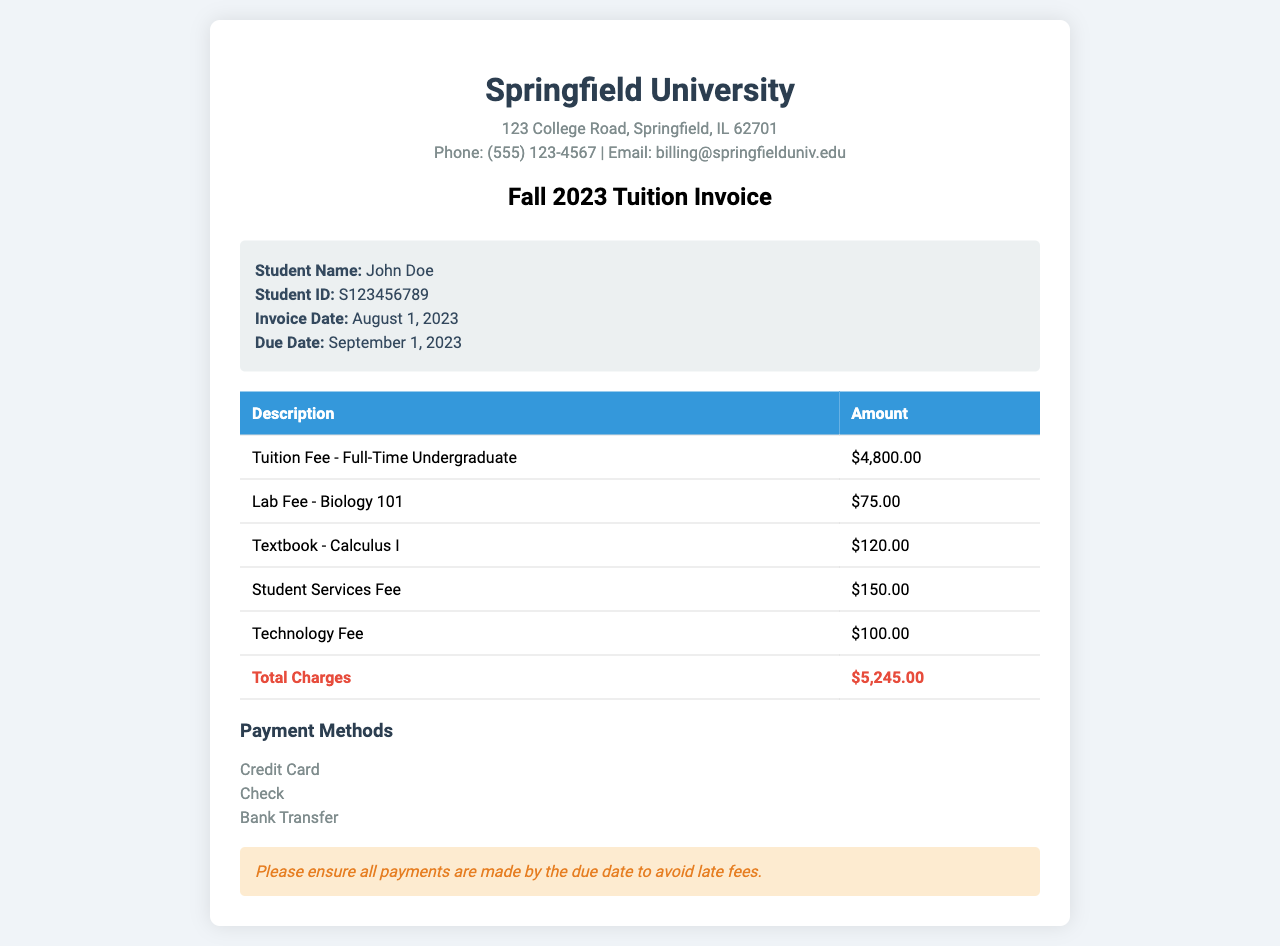What is the total amount due on the invoice? The total amount due is clearly listed in the document as the "Total Charges," which sums up all itemized fees.
Answer: $5,245.00 Who is the student named in the invoice? The invoice includes a specific section for student information, where the student's name is provided.
Answer: John Doe What is the invoice date? The invoice date is a specific date found in the student info section of the document.
Answer: August 1, 2023 What are the payment methods listed? The document specifies various payment options, which are presented in a list format under the payment methods section.
Answer: Credit Card, Check, Bank Transfer What is the charge for the Technology Fee? Each individual charge is itemized, including the Technology Fee, which is listed with its amount.
Answer: $100.00 How much is the Tuition Fee for Full-Time Undergraduate? The document indicates the cost of full-time undergraduate tuition in the itemized charges table.
Answer: $4,800.00 When is the payment due date? The due date for payment is explicitly stated in the student info section of the invoice.
Answer: September 1, 2023 What is the additional charge for the Lab Fee - Biology 101? The itemized charges list includes a specific fee for the Lab associated with a course.
Answer: $75.00 What is the purpose of the notes section? The notes section provides warnings or additional information and serves a specific purpose in financial documents.
Answer: To inform about late fees 